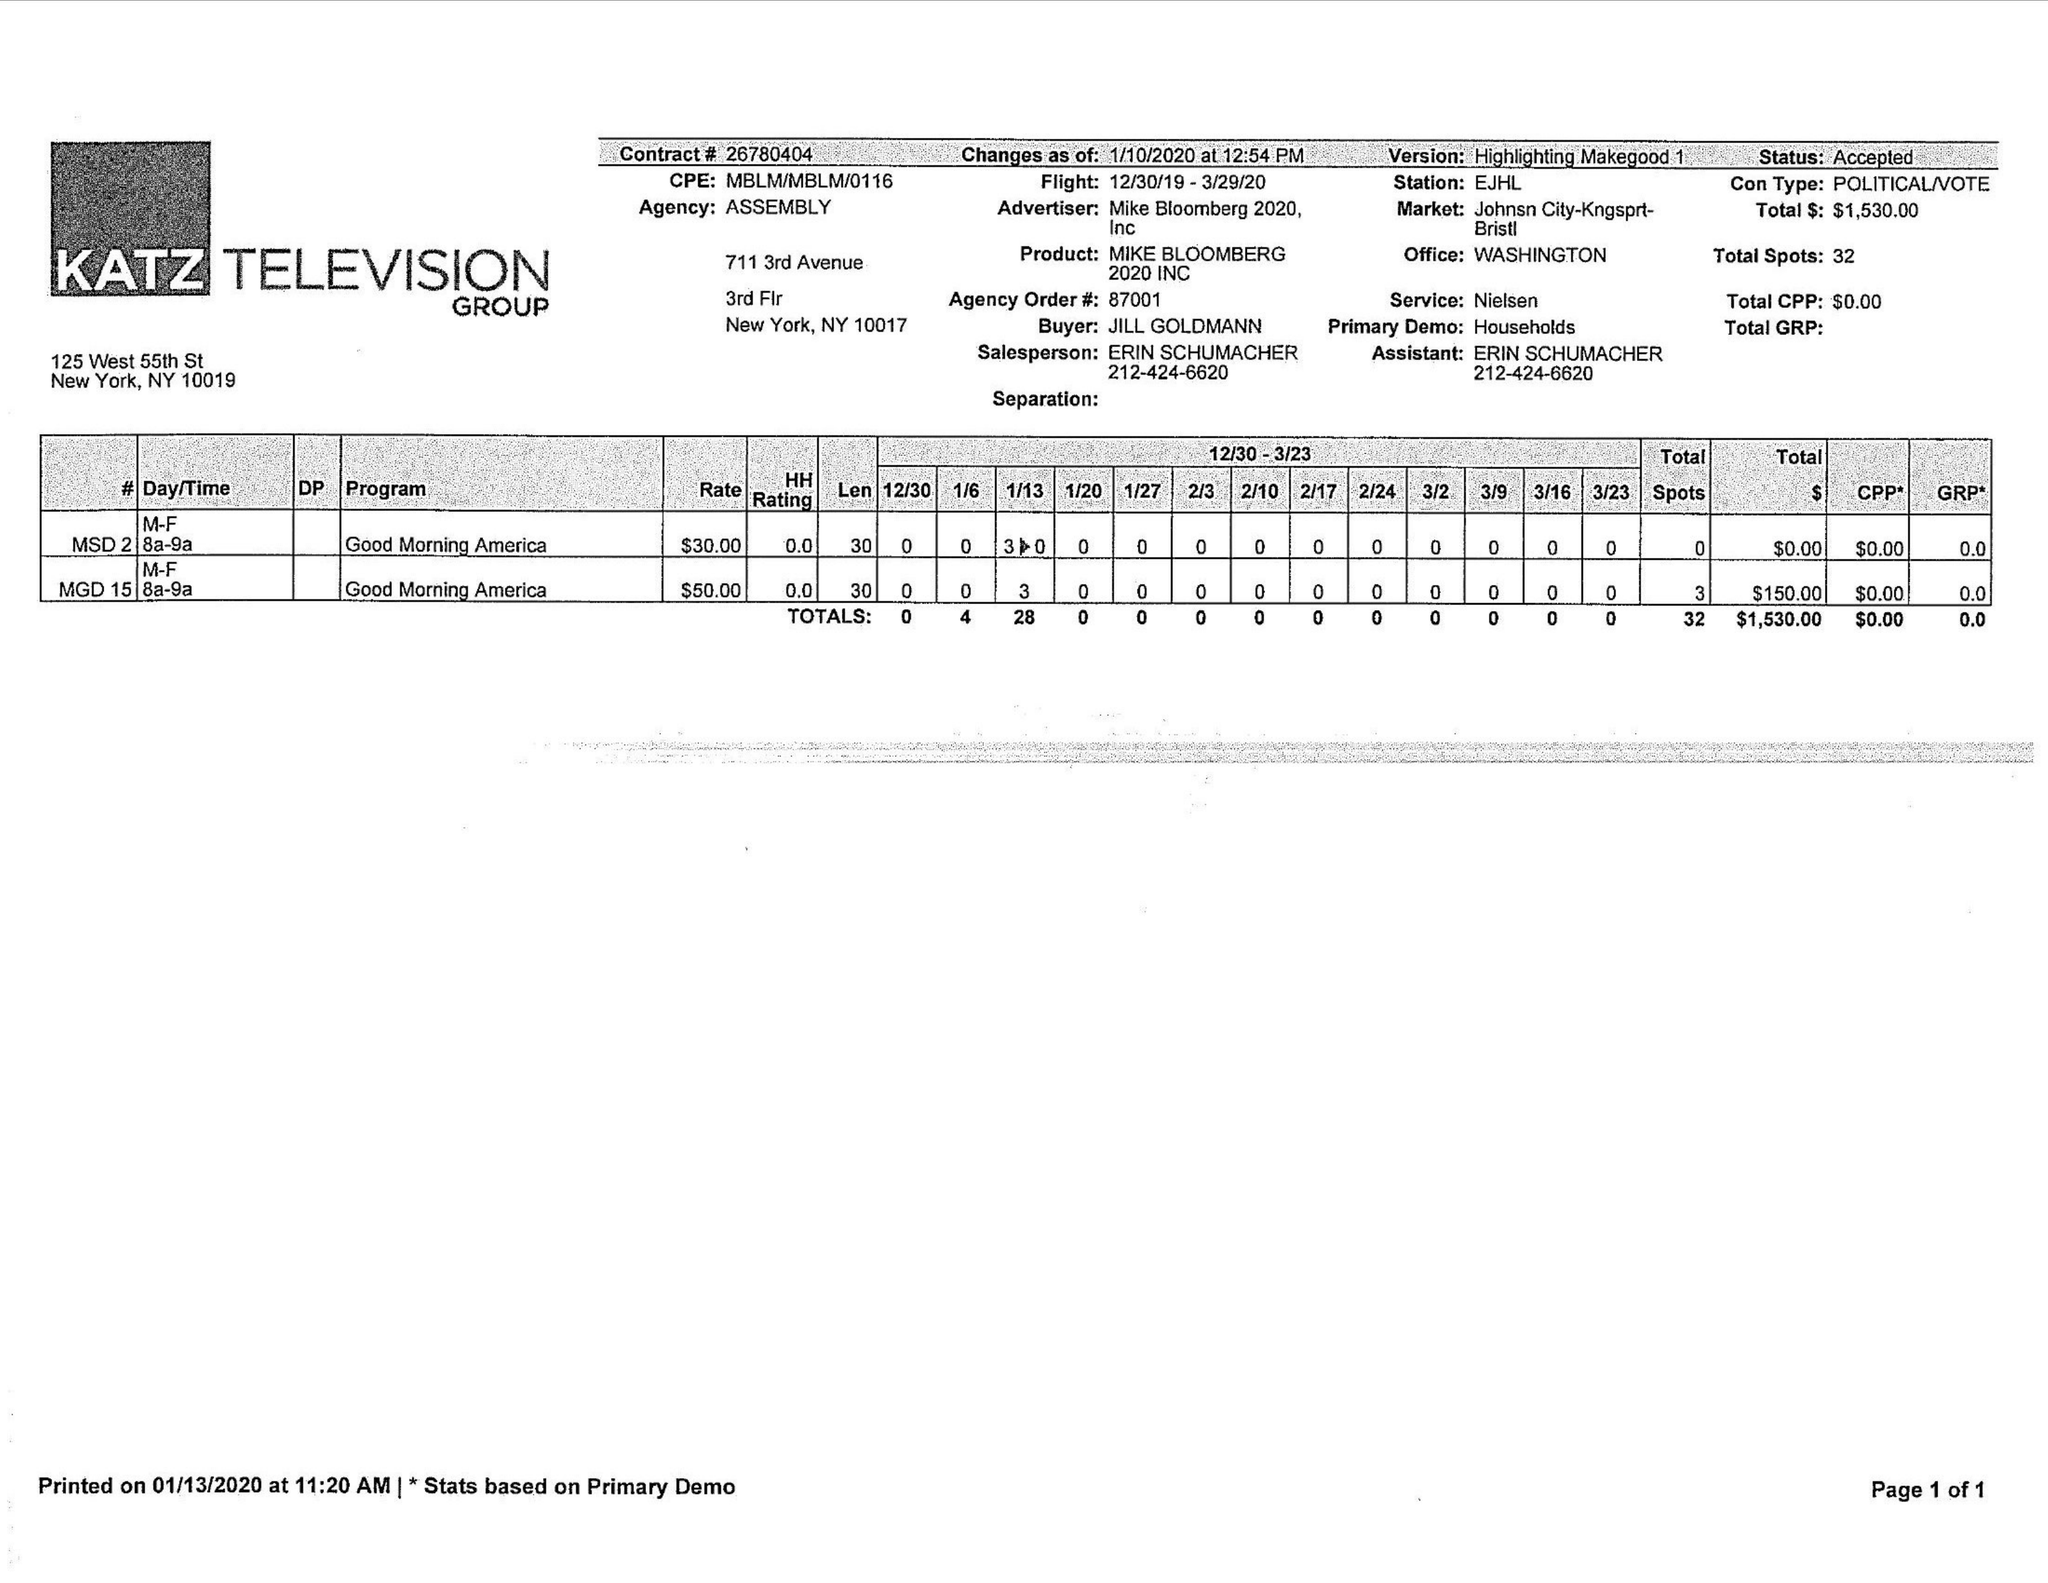What is the value for the advertiser?
Answer the question using a single word or phrase. MIKE BLOOMBERG 2020, INC 